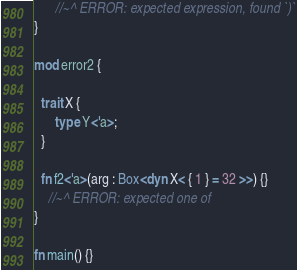<code> <loc_0><loc_0><loc_500><loc_500><_Rust_>      //~^ ERROR: expected expression, found `)`
}

mod error2 {

  trait X {
      type Y<'a>;
  }

  fn f2<'a>(arg : Box<dyn X< { 1 } = 32 >>) {}
    //~^ ERROR: expected one of
}

fn main() {}
</code> 